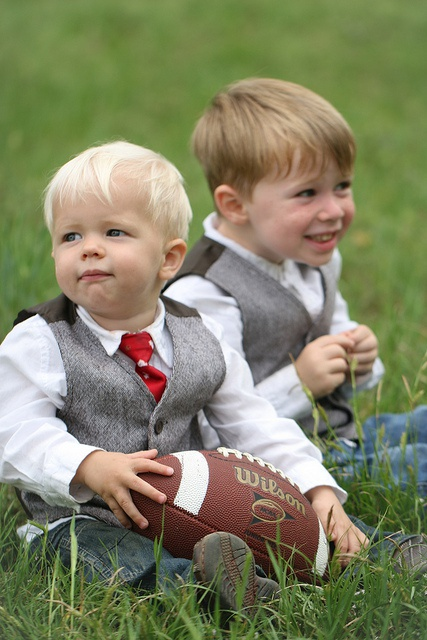Describe the objects in this image and their specific colors. I can see people in olive, lightgray, gray, darkgray, and tan tones, people in olive, gray, tan, and darkgray tones, sports ball in olive, maroon, brown, black, and white tones, and tie in olive, brown, maroon, and darkgray tones in this image. 